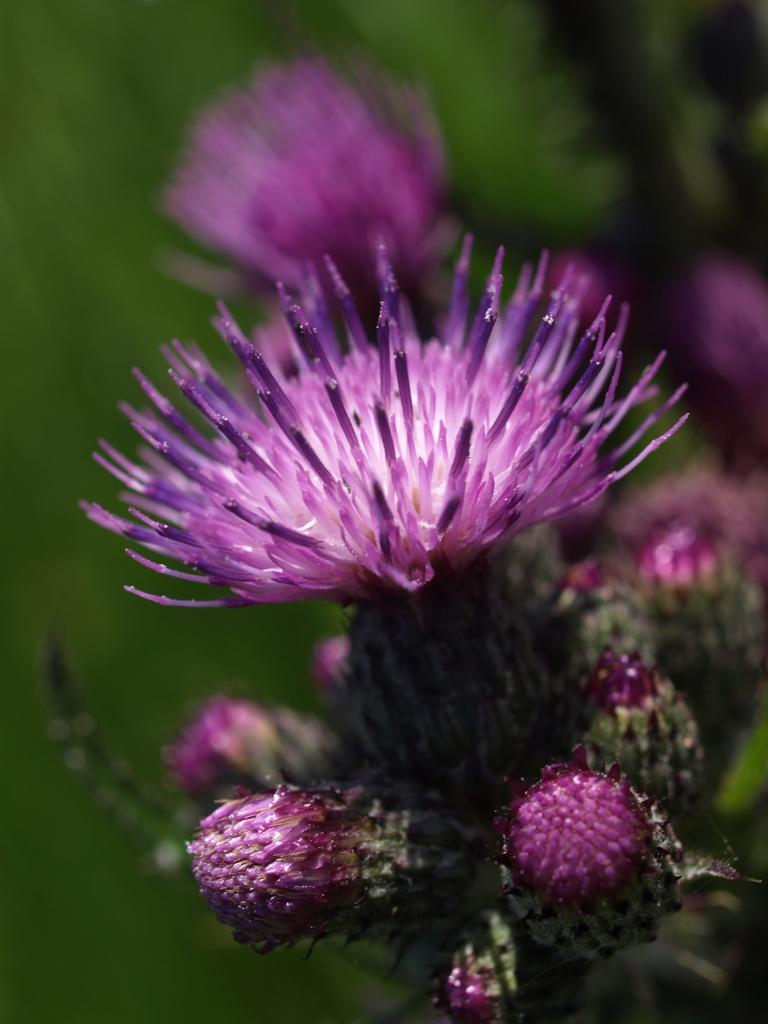What type of plants are in the image? There are flowers in the image. What color are the flowers? The flowers are purple in color. What stage of growth are the flowers in? There are buds in the image, which suggests that some flowers are still in the process of blooming. What color is the background of the image? The background of the image is green. What type of salt can be seen on the ground in the image? There is no salt present in the image; it features flowers with a green background. 